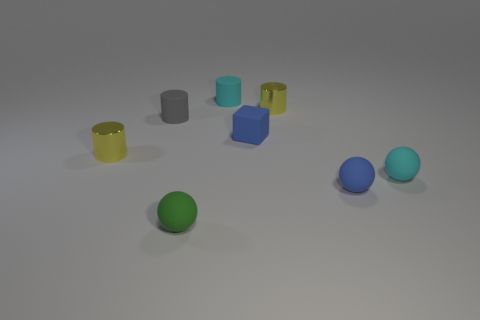Add 2 tiny objects. How many objects exist? 10 Subtract all blocks. How many objects are left? 7 Add 3 big green balls. How many big green balls exist? 3 Subtract 0 green cubes. How many objects are left? 8 Subtract all large yellow metal spheres. Subtract all small cubes. How many objects are left? 7 Add 8 gray cylinders. How many gray cylinders are left? 9 